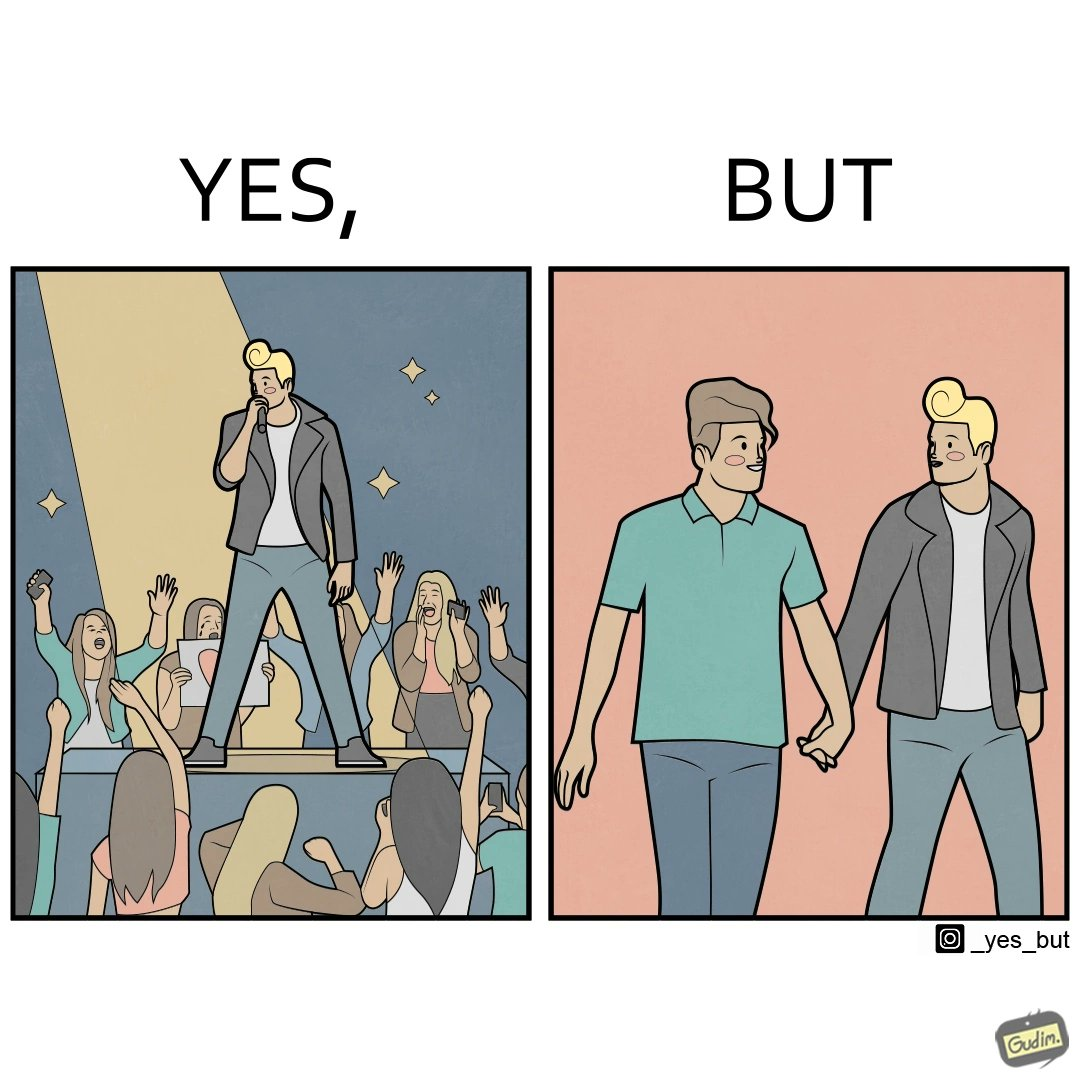Describe the content of this image. The image is funny because while the girls loves the man, he likes other men instead of women. 